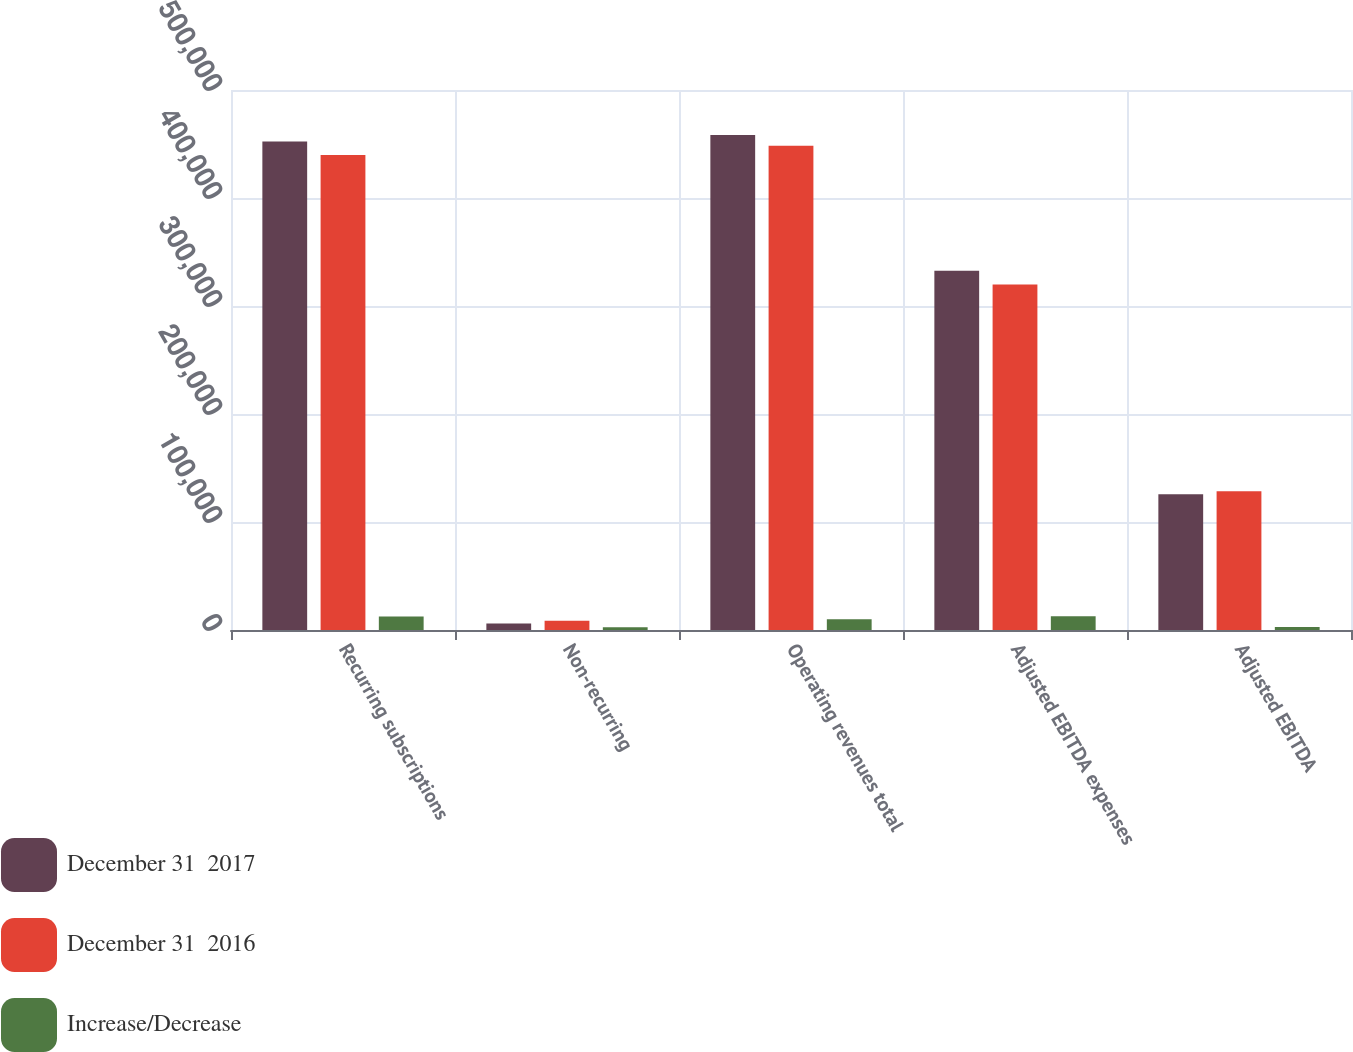<chart> <loc_0><loc_0><loc_500><loc_500><stacked_bar_chart><ecel><fcel>Recurring subscriptions<fcel>Non-recurring<fcel>Operating revenues total<fcel>Adjusted EBITDA expenses<fcel>Adjusted EBITDA<nl><fcel>December 31  2017<fcel>452253<fcel>6016<fcel>458269<fcel>332645<fcel>125624<nl><fcel>December 31  2016<fcel>439864<fcel>8489<fcel>448353<fcel>319846<fcel>128507<nl><fcel>Increase/Decrease<fcel>12389<fcel>2473<fcel>9916<fcel>12799<fcel>2883<nl></chart> 